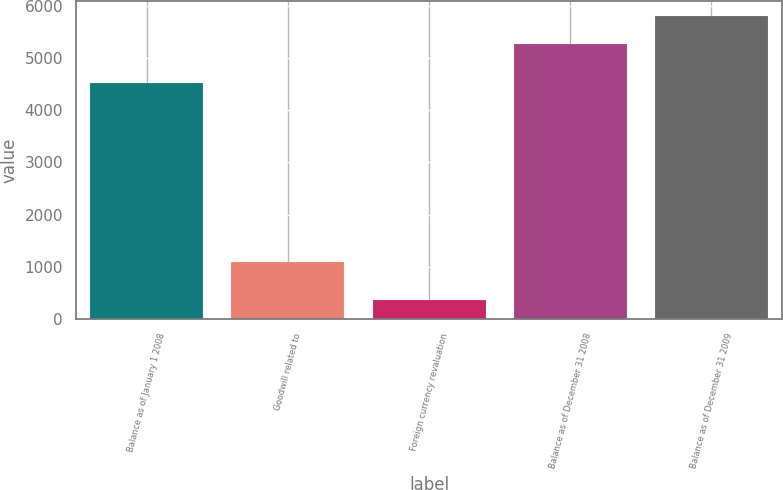Convert chart to OTSL. <chart><loc_0><loc_0><loc_500><loc_500><bar_chart><fcel>Balance as of January 1 2008<fcel>Goodwill related to<fcel>Foreign currency revaluation<fcel>Balance as of December 31 2008<fcel>Balance as of December 31 2009<nl><fcel>4527<fcel>1099<fcel>362<fcel>5259<fcel>5792.1<nl></chart> 